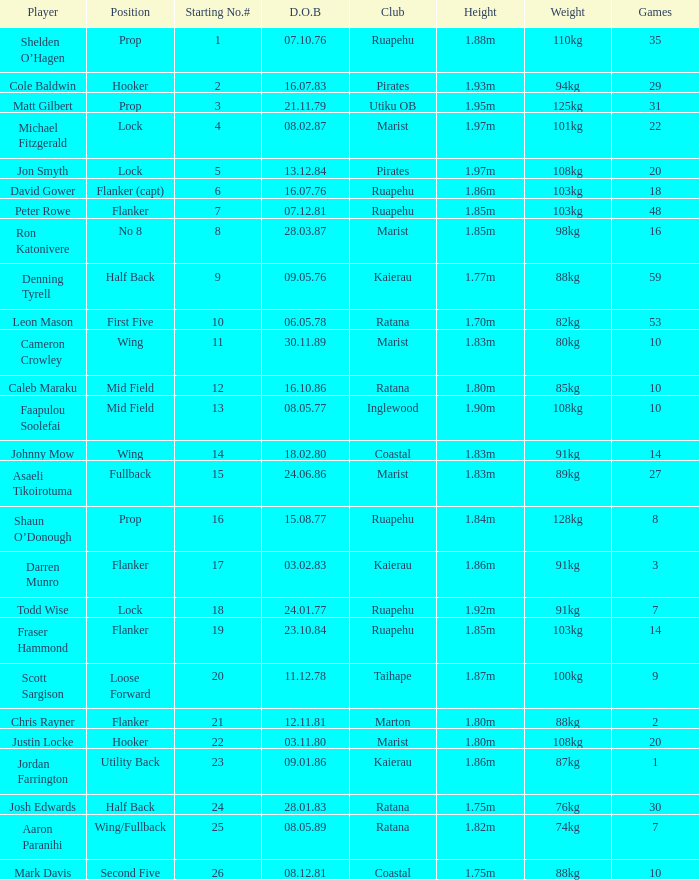Which participant weighs 76kg? Josh Edwards. 